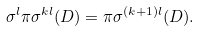<formula> <loc_0><loc_0><loc_500><loc_500>\sigma ^ { l } \pi \sigma ^ { k l } ( D ) = \pi \sigma ^ { ( k + 1 ) l } ( D ) .</formula> 